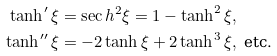<formula> <loc_0><loc_0><loc_500><loc_500>\tanh ^ { \prime } \xi & = \sec h ^ { 2 } \xi = 1 - \tanh ^ { 2 } \xi , \\ \tanh ^ { \prime \prime } \xi & = - 2 \tanh \xi + 2 \tanh ^ { 3 } \xi , \text { etc.}</formula> 